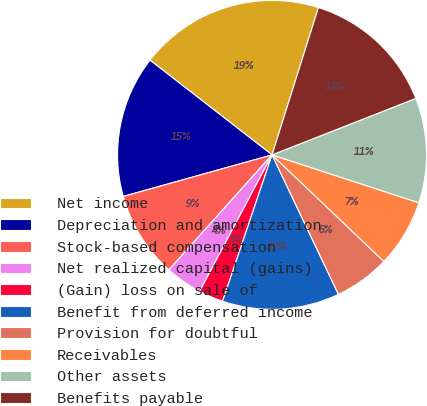Convert chart. <chart><loc_0><loc_0><loc_500><loc_500><pie_chart><fcel>Net income<fcel>Depreciation and amortization<fcel>Stock-based compensation<fcel>Net realized capital (gains)<fcel>(Gain) loss on sale of<fcel>Benefit from deferred income<fcel>Provision for doubtful<fcel>Receivables<fcel>Other assets<fcel>Benefits payable<nl><fcel>19.35%<fcel>14.84%<fcel>9.03%<fcel>3.87%<fcel>2.58%<fcel>12.26%<fcel>5.81%<fcel>7.1%<fcel>10.97%<fcel>14.19%<nl></chart> 